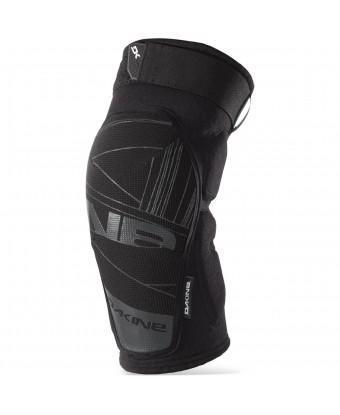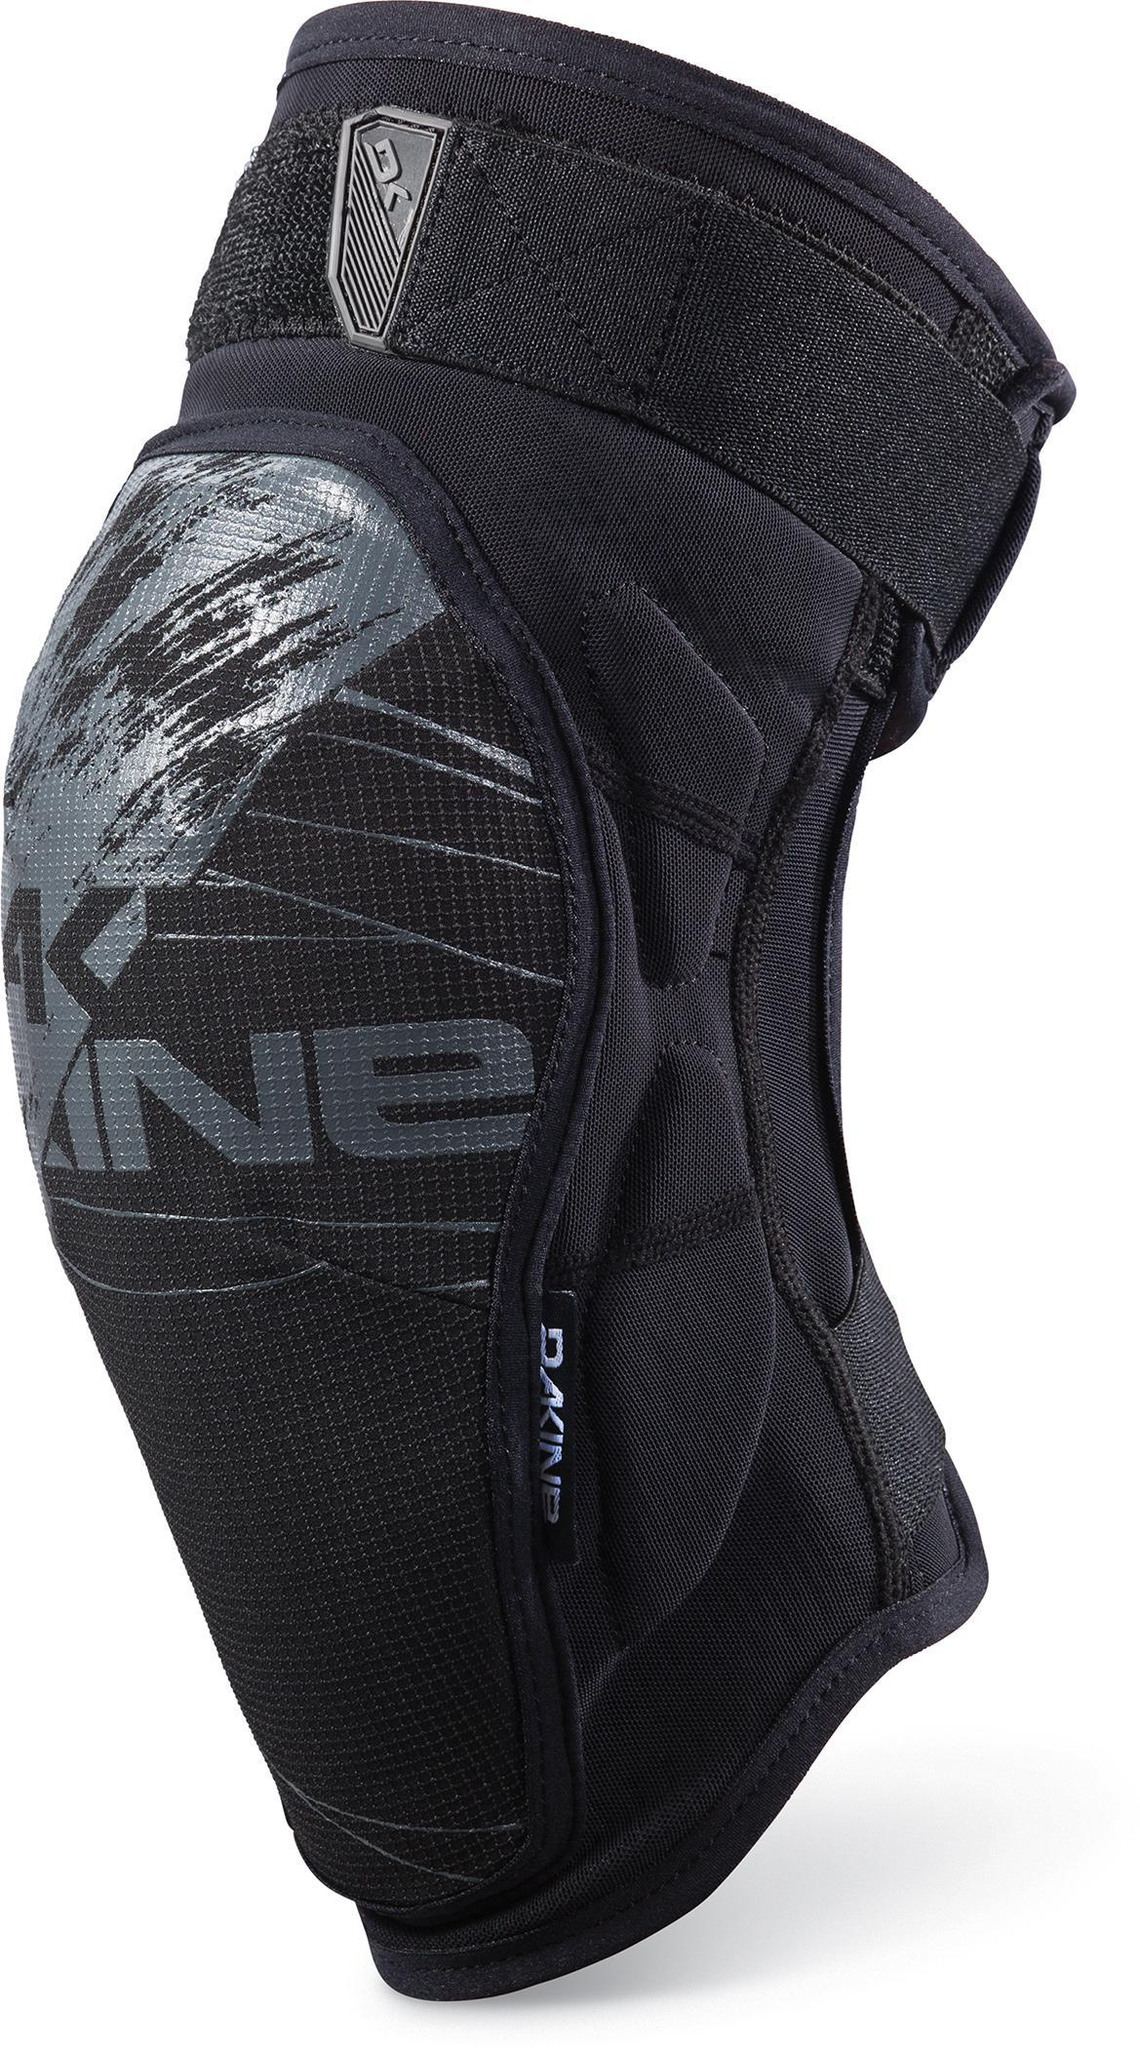The first image is the image on the left, the second image is the image on the right. Analyze the images presented: Is the assertion "Both pads are facing in the same direction." valid? Answer yes or no. Yes. 